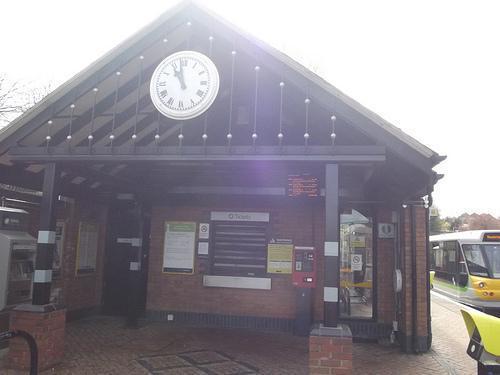How many clocks are there?
Give a very brief answer. 1. 